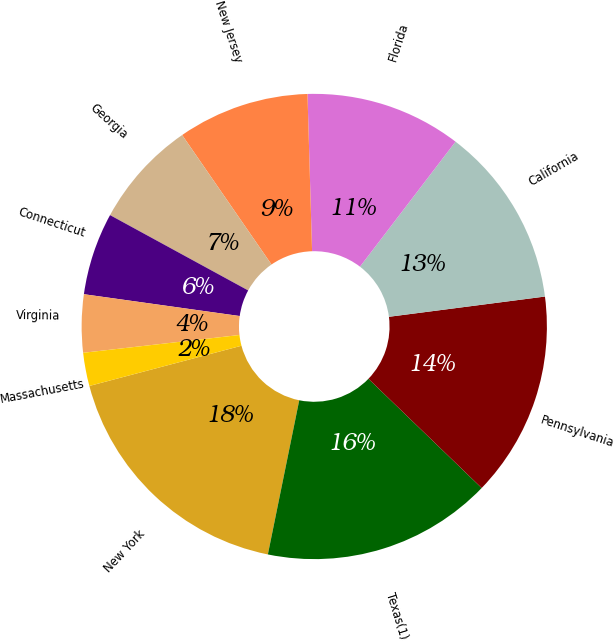Convert chart. <chart><loc_0><loc_0><loc_500><loc_500><pie_chart><fcel>New York<fcel>Texas(1)<fcel>Pennsylvania<fcel>California<fcel>Florida<fcel>New Jersey<fcel>Georgia<fcel>Connecticut<fcel>Virginia<fcel>Massachusetts<nl><fcel>17.69%<fcel>15.98%<fcel>14.27%<fcel>12.56%<fcel>10.85%<fcel>9.15%<fcel>7.44%<fcel>5.73%<fcel>4.02%<fcel>2.31%<nl></chart> 